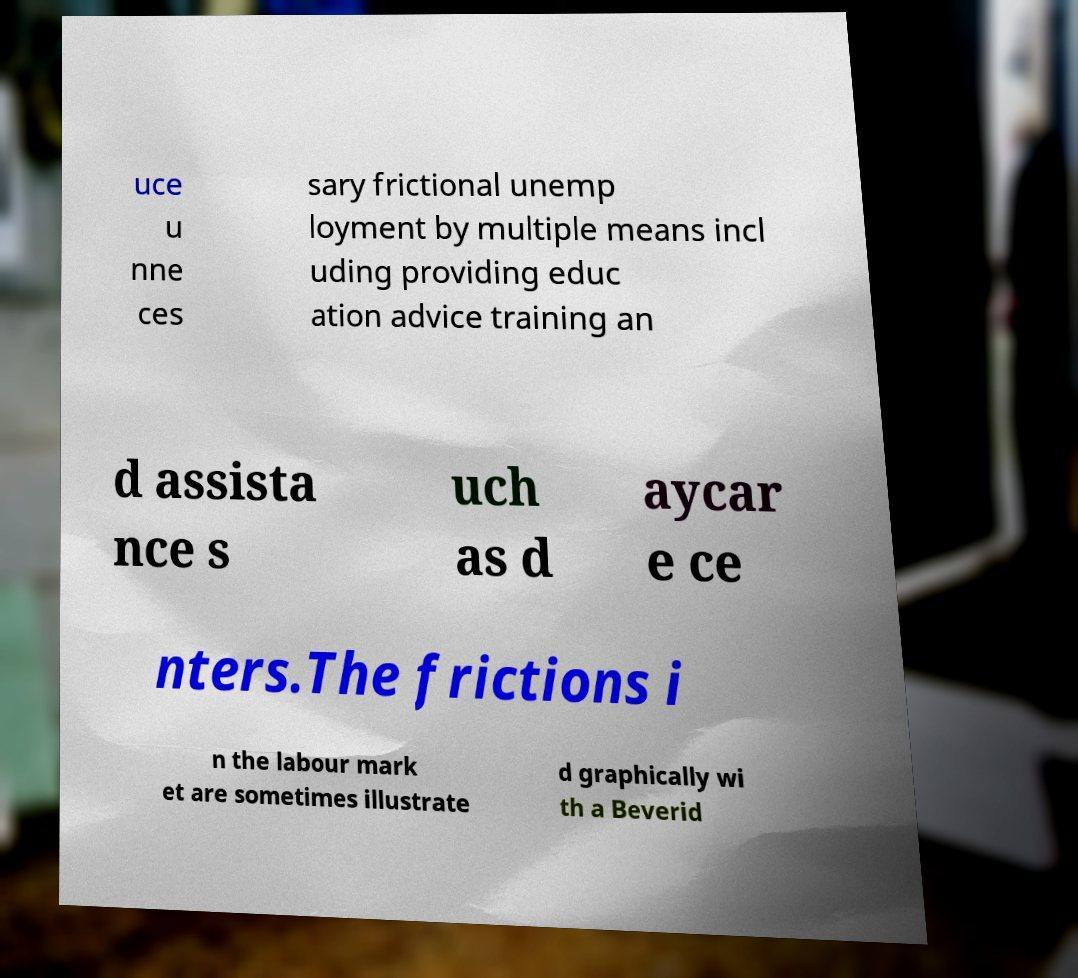I need the written content from this picture converted into text. Can you do that? uce u nne ces sary frictional unemp loyment by multiple means incl uding providing educ ation advice training an d assista nce s uch as d aycar e ce nters.The frictions i n the labour mark et are sometimes illustrate d graphically wi th a Beverid 